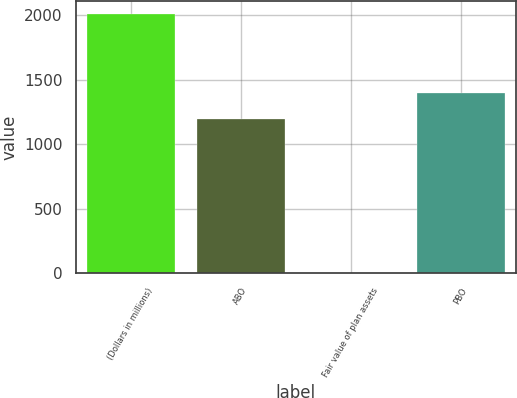Convert chart. <chart><loc_0><loc_0><loc_500><loc_500><bar_chart><fcel>(Dollars in millions)<fcel>ABO<fcel>Fair value of plan assets<fcel>PBO<nl><fcel>2010<fcel>1199<fcel>2<fcel>1399.8<nl></chart> 